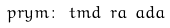<formula> <loc_0><loc_0><loc_500><loc_500>\ p r y m \colon \ t m d \ r a \ a d a</formula> 